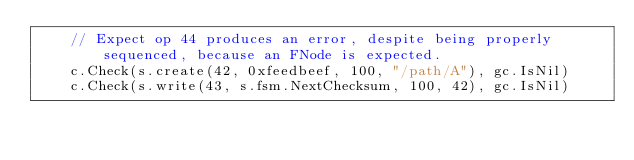<code> <loc_0><loc_0><loc_500><loc_500><_Go_>	// Expect op 44 produces an error, despite being properly sequenced, because an FNode is expected.
	c.Check(s.create(42, 0xfeedbeef, 100, "/path/A"), gc.IsNil)
	c.Check(s.write(43, s.fsm.NextChecksum, 100, 42), gc.IsNil)</code> 